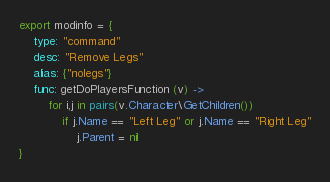Convert code to text. <code><loc_0><loc_0><loc_500><loc_500><_MoonScript_>export modinfo = {
	type: "command"
	desc: "Remove Legs"
	alias: {"nolegs"}
	func: getDoPlayersFunction (v) ->
		for i,j in pairs(v.Character\GetChildren())
			if j.Name == "Left Leg" or j.Name == "Right Leg"
				j.Parent = nil
}</code> 